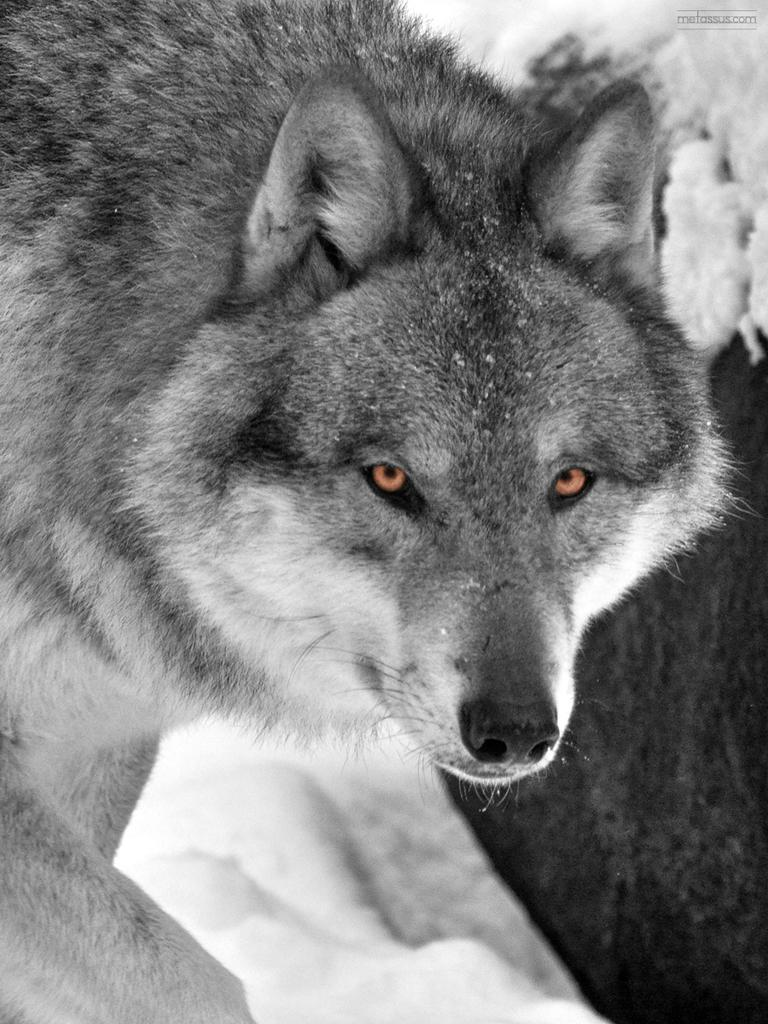What type of animal is in the image? There is a grey color wolf in the image. Can you describe any additional features of the image? Yes, there is a watermark on the image. What type of ghost can be seen interacting with the wolf in the image? There is no ghost present in the image; it features a grey color wolf and a watermark. What type of disease is affecting the wolf in the image? There is no indication of any disease affecting the wolf in the image. 